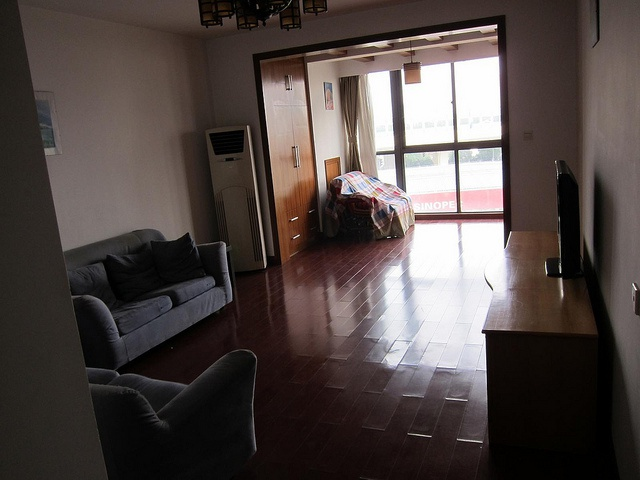Describe the objects in this image and their specific colors. I can see couch in black and gray tones, couch in black, lightgray, maroon, and darkgray tones, and tv in black and gray tones in this image. 